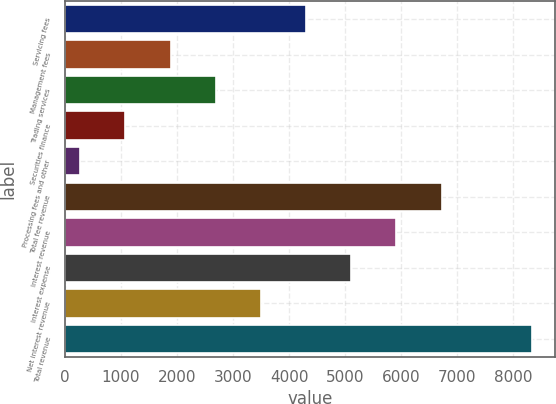<chart> <loc_0><loc_0><loc_500><loc_500><bar_chart><fcel>Servicing fees<fcel>Management fees<fcel>Trading services<fcel>Securities finance<fcel>Processing fees and other<fcel>Total fee revenue<fcel>Interest revenue<fcel>Interest expense<fcel>Net interest revenue<fcel>Total revenue<nl><fcel>4303.5<fcel>1884<fcel>2690.5<fcel>1077.5<fcel>271<fcel>6723<fcel>5916.5<fcel>5110<fcel>3497<fcel>8336<nl></chart> 